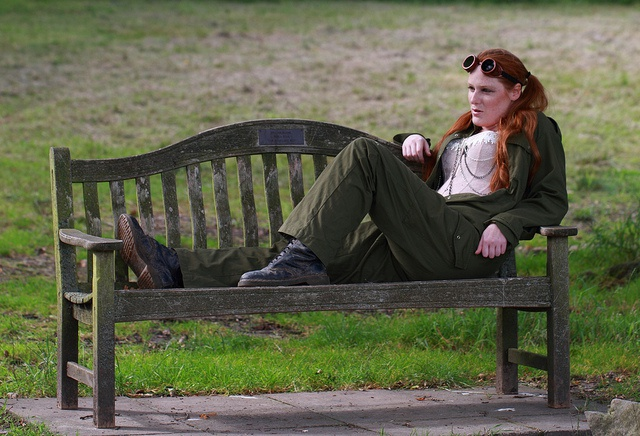Describe the objects in this image and their specific colors. I can see bench in darkgreen, black, gray, and olive tones and people in darkgreen, black, gray, maroon, and brown tones in this image. 